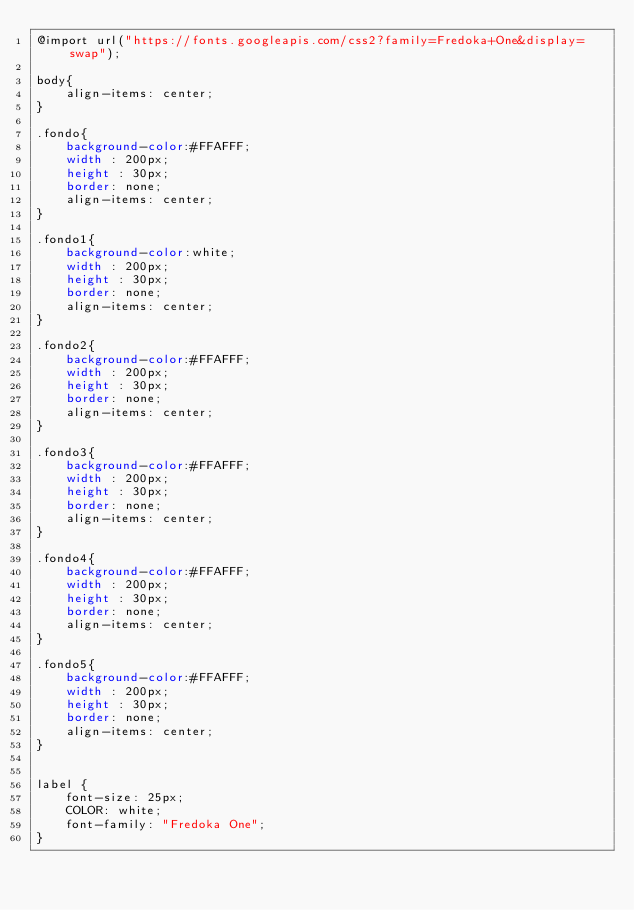Convert code to text. <code><loc_0><loc_0><loc_500><loc_500><_CSS_>@import url("https://fonts.googleapis.com/css2?family=Fredoka+One&display=swap");

body{
	align-items: center;
}

.fondo{
	background-color:#FFAFFF;
	width : 200px; 
	height : 30px;
	border: none;
	align-items: center;
}

.fondo1{
	background-color:white;
	width : 200px; 
	height : 30px;
	border: none;
	align-items: center;
}

.fondo2{
	background-color:#FFAFFF;
	width : 200px; 
	height : 30px;
	border: none;
	align-items: center;
}

.fondo3{
	background-color:#FFAFFF;
	width : 200px; 
	height : 30px;
	border: none;
	align-items: center;
}

.fondo4{
	background-color:#FFAFFF;
	width : 200px; 
	height : 30px;
	border: none;
	align-items: center;
}

.fondo5{
	background-color:#FFAFFF;
	width : 200px; 
	height : 30px;
	border: none;
	align-items: center;
}


label {
    font-size: 25px;
    COLOR: white;
    font-family: "Fredoka One";
}</code> 